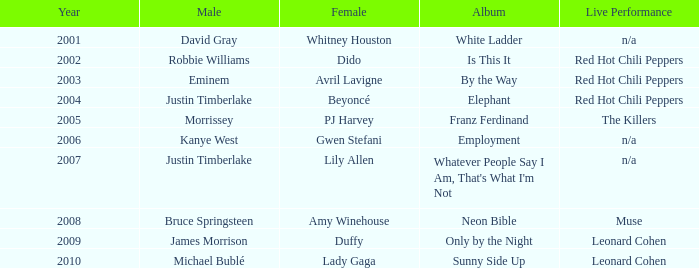Which male is paired with dido in 2004? Robbie Williams. Parse the table in full. {'header': ['Year', 'Male', 'Female', 'Album', 'Live Performance'], 'rows': [['2001', 'David Gray', 'Whitney Houston', 'White Ladder', 'n/a'], ['2002', 'Robbie Williams', 'Dido', 'Is This It', 'Red Hot Chili Peppers'], ['2003', 'Eminem', 'Avril Lavigne', 'By the Way', 'Red Hot Chili Peppers'], ['2004', 'Justin Timberlake', 'Beyoncé', 'Elephant', 'Red Hot Chili Peppers'], ['2005', 'Morrissey', 'PJ Harvey', 'Franz Ferdinand', 'The Killers'], ['2006', 'Kanye West', 'Gwen Stefani', 'Employment', 'n/a'], ['2007', 'Justin Timberlake', 'Lily Allen', "Whatever People Say I Am, That's What I'm Not", 'n/a'], ['2008', 'Bruce Springsteen', 'Amy Winehouse', 'Neon Bible', 'Muse'], ['2009', 'James Morrison', 'Duffy', 'Only by the Night', 'Leonard Cohen'], ['2010', 'Michael Bublé', 'Lady Gaga', 'Sunny Side Up', 'Leonard Cohen']]} 